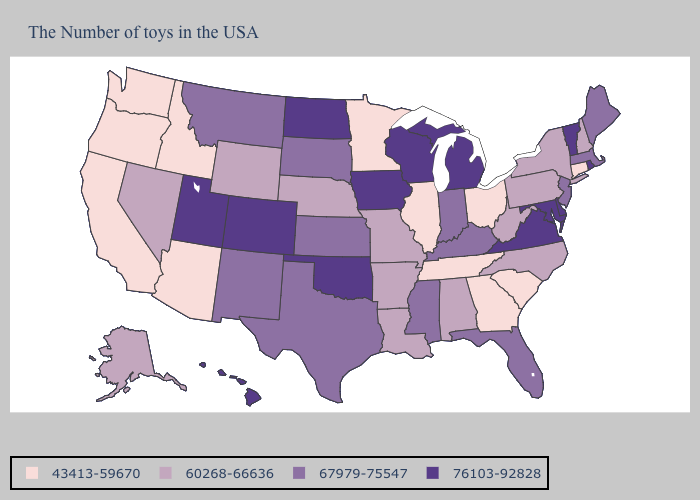Does Wisconsin have the highest value in the USA?
Give a very brief answer. Yes. What is the lowest value in the USA?
Be succinct. 43413-59670. What is the highest value in the USA?
Quick response, please. 76103-92828. Name the states that have a value in the range 60268-66636?
Answer briefly. New Hampshire, New York, Pennsylvania, North Carolina, West Virginia, Alabama, Louisiana, Missouri, Arkansas, Nebraska, Wyoming, Nevada, Alaska. Does the map have missing data?
Write a very short answer. No. Does Mississippi have the lowest value in the USA?
Quick response, please. No. Does the map have missing data?
Be succinct. No. Does South Dakota have a lower value than North Dakota?
Give a very brief answer. Yes. Among the states that border Nevada , does Utah have the highest value?
Concise answer only. Yes. What is the highest value in states that border Louisiana?
Keep it brief. 67979-75547. Does the first symbol in the legend represent the smallest category?
Write a very short answer. Yes. What is the value of Georgia?
Short answer required. 43413-59670. What is the value of Florida?
Be succinct. 67979-75547. Does Indiana have the same value as Connecticut?
Be succinct. No. Does Illinois have the highest value in the MidWest?
Short answer required. No. 